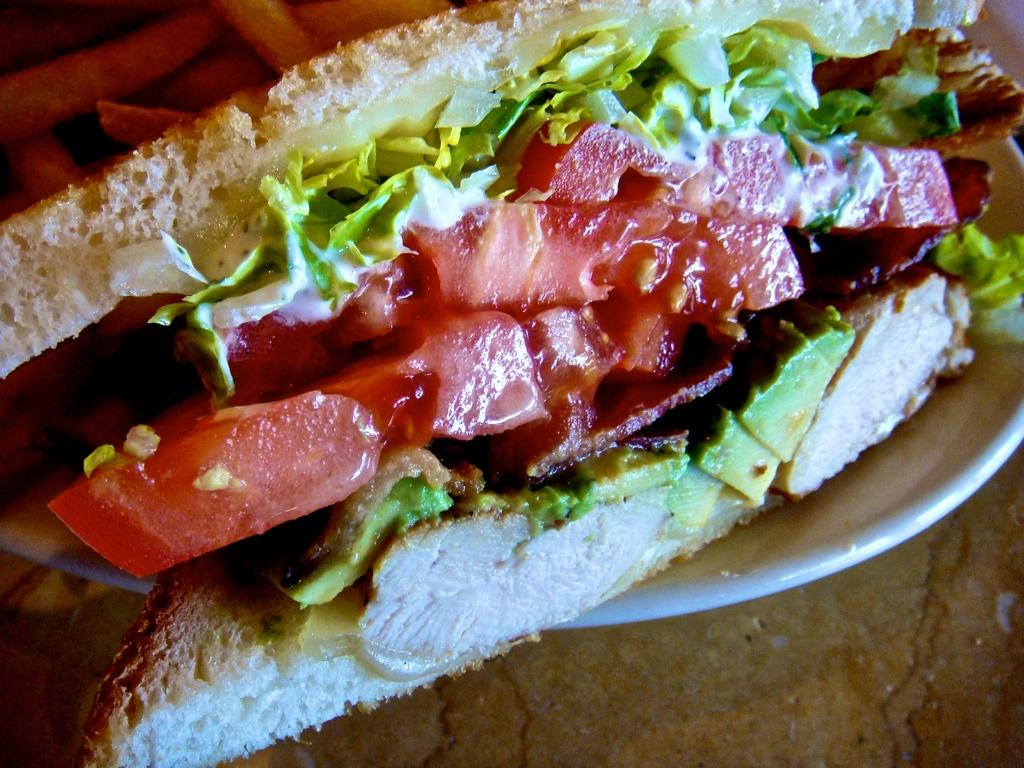What type of food can be seen in the image? There is a sandwich and french fries in the image. What is the color of the bowl in the image? The bowl in the image is white. What color is present at the bottom of the image? The bottom of the image has a brown color. Where is the kettle located in the image? There is no kettle present in the image. What type of reward is being given to the person in the image? There is no person or reward present in the image. 